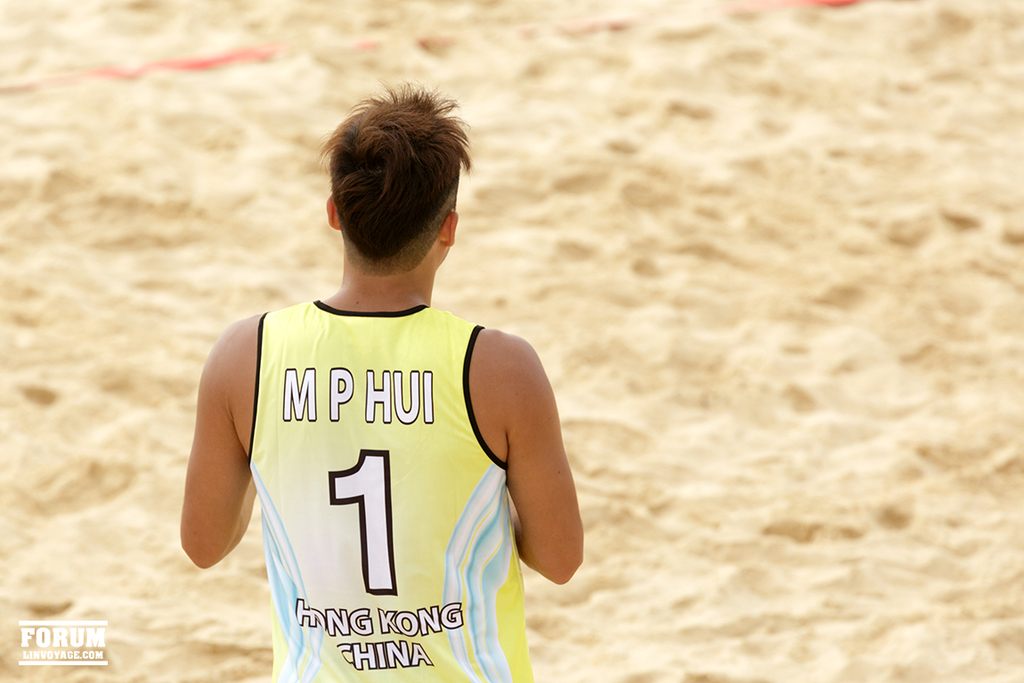What does the jersey worn by the person in the image signify about the event or location where this photo was taken? The jersey, prominently featuring 'Hong Kong China', suggests that the individual is likely participating in an international sporting event, possibly a beach volleyball match, where he represents the Hong Kong team. 